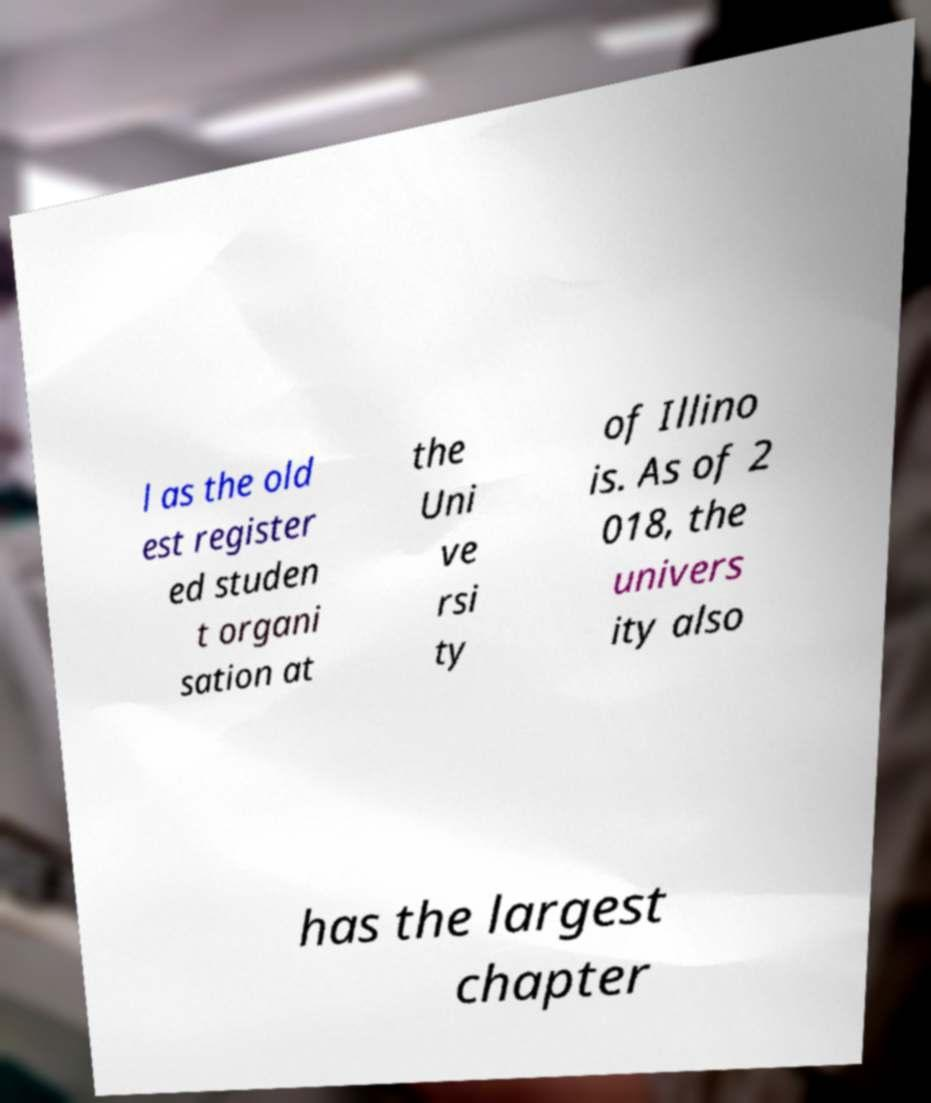What messages or text are displayed in this image? I need them in a readable, typed format. l as the old est register ed studen t organi sation at the Uni ve rsi ty of Illino is. As of 2 018, the univers ity also has the largest chapter 